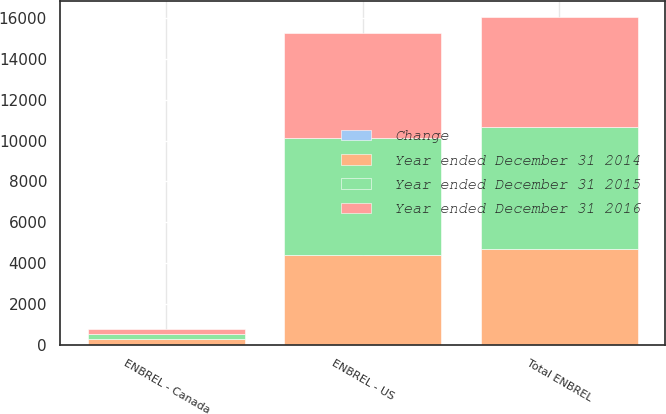Convert chart to OTSL. <chart><loc_0><loc_0><loc_500><loc_500><stacked_bar_chart><ecel><fcel>ENBREL - US<fcel>ENBREL - Canada<fcel>Total ENBREL<nl><fcel>Year ended December 31 2015<fcel>5719<fcel>246<fcel>5965<nl><fcel>Change<fcel>12<fcel>7<fcel>11<nl><fcel>Year ended December 31 2016<fcel>5099<fcel>265<fcel>5364<nl><fcel>Year ended December 31 2014<fcel>4404<fcel>284<fcel>4688<nl></chart> 